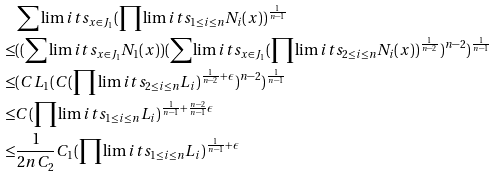Convert formula to latex. <formula><loc_0><loc_0><loc_500><loc_500>& \sum \lim i t s _ { x \in J _ { 1 } } ( \prod \lim i t s _ { 1 \leq i \leq n } N _ { i } ( x ) ) ^ { \frac { 1 } { n - 1 } } \\ \leq & ( ( \sum \lim i t s _ { x \in J _ { 1 } } N _ { 1 } ( x ) ) ( \sum \lim i t s _ { x \in J _ { 1 } } ( \prod \lim i t s _ { 2 \leq i \leq n } N _ { i } ( x ) ) ^ { \frac { 1 } { n - 2 } } ) ^ { n - 2 } ) ^ { \frac { 1 } { n - 1 } } \\ \leq & ( C L _ { 1 } ( C ( \prod \lim i t s _ { 2 \leq i \leq n } L _ { i } ) ^ { \frac { 1 } { n - 2 } + \epsilon } ) ^ { n - 2 } ) ^ { \frac { 1 } { n - 1 } } \\ \leq & C ( \prod \lim i t s _ { 1 \leq i \leq n } L _ { i } ) ^ { \frac { 1 } { n - 1 } + \frac { n - 2 } { n - 1 } \epsilon } \\ \leq & \frac { 1 } { 2 n C _ { 2 } } C _ { 1 } ( \prod \lim i t s _ { 1 \leq i \leq n } L _ { i } ) ^ { \frac { 1 } { n - 1 } + \epsilon }</formula> 